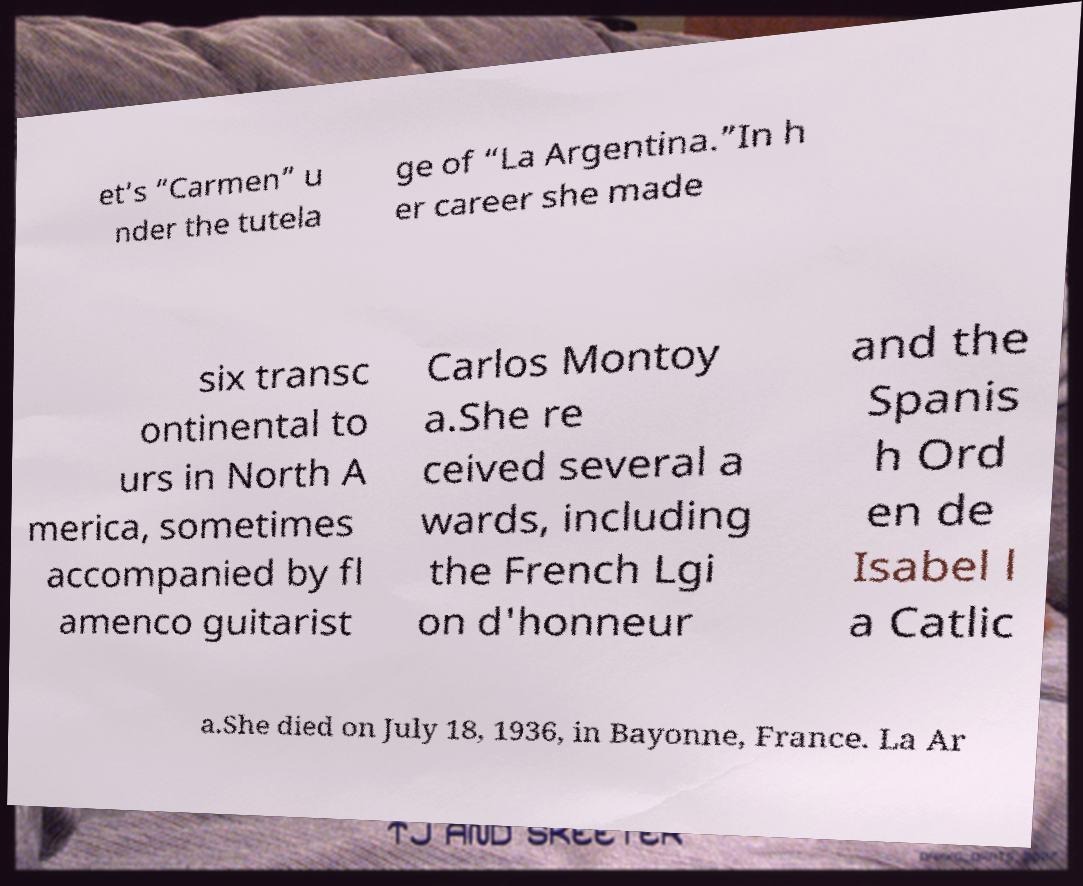There's text embedded in this image that I need extracted. Can you transcribe it verbatim? et’s “Carmen” u nder the tutela ge of “La Argentina.”In h er career she made six transc ontinental to urs in North A merica, sometimes accompanied by fl amenco guitarist Carlos Montoy a.She re ceived several a wards, including the French Lgi on d'honneur and the Spanis h Ord en de Isabel l a Catlic a.She died on July 18, 1936, in Bayonne, France. La Ar 